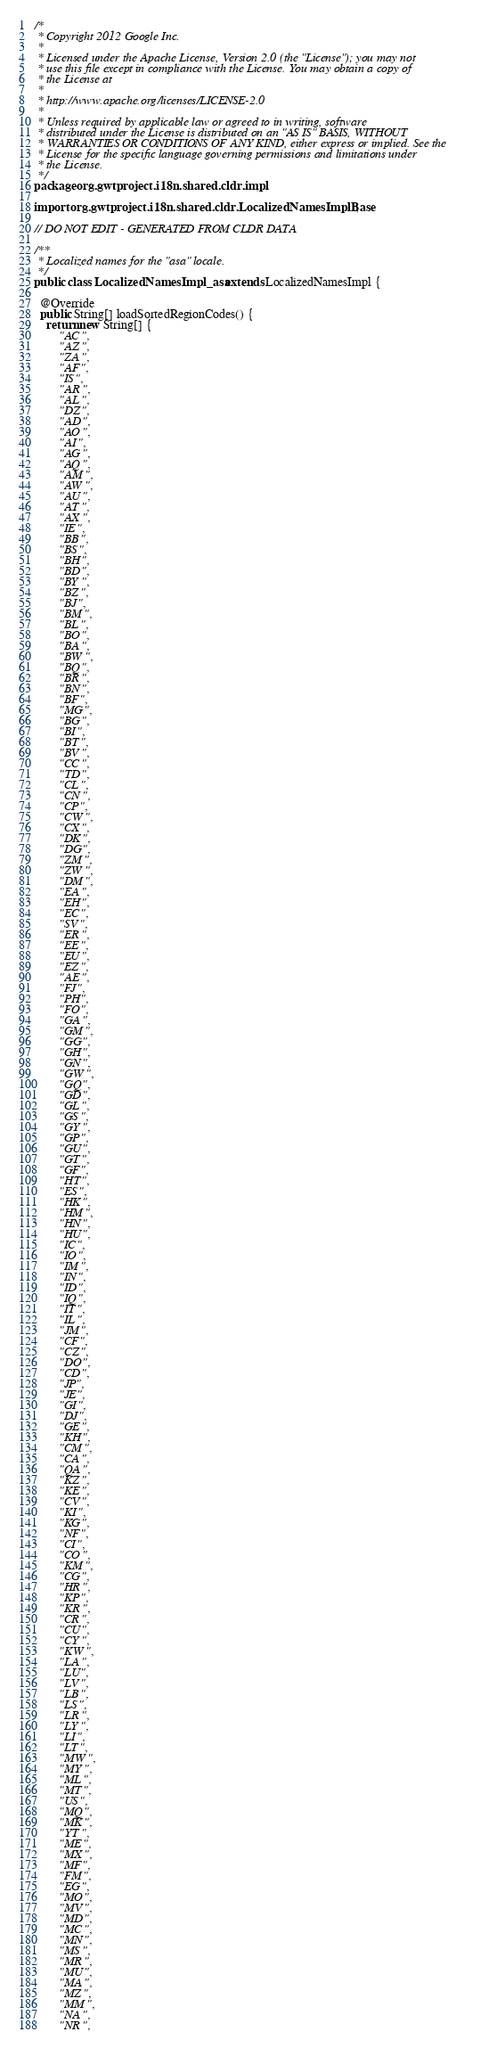<code> <loc_0><loc_0><loc_500><loc_500><_Java_>/*
 * Copyright 2012 Google Inc.
 * 
 * Licensed under the Apache License, Version 2.0 (the "License"); you may not
 * use this file except in compliance with the License. You may obtain a copy of
 * the License at
 * 
 * http://www.apache.org/licenses/LICENSE-2.0
 * 
 * Unless required by applicable law or agreed to in writing, software
 * distributed under the License is distributed on an "AS IS" BASIS, WITHOUT
 * WARRANTIES OR CONDITIONS OF ANY KIND, either express or implied. See the
 * License for the specific language governing permissions and limitations under
 * the License.
 */
package org.gwtproject.i18n.shared.cldr.impl;

import org.gwtproject.i18n.shared.cldr.LocalizedNamesImplBase;

// DO NOT EDIT - GENERATED FROM CLDR DATA

/**
 * Localized names for the "asa" locale.
 */
public class LocalizedNamesImpl_asa extends LocalizedNamesImpl {

  @Override
  public String[] loadSortedRegionCodes() {
    return new String[] {
        "AC",
        "AZ",
        "ZA",
        "AF",
        "IS",
        "AR",
        "AL",
        "DZ",
        "AD",
        "AO",
        "AI",
        "AG",
        "AQ",
        "AM",
        "AW",
        "AU",
        "AT",
        "AX",
        "IE",
        "BB",
        "BS",
        "BH",
        "BD",
        "BY",
        "BZ",
        "BJ",
        "BM",
        "BL",
        "BO",
        "BA",
        "BW",
        "BQ",
        "BR",
        "BN",
        "BF",
        "MG",
        "BG",
        "BI",
        "BT",
        "BV",
        "CC",
        "TD",
        "CL",
        "CN",
        "CP",
        "CW",
        "CX",
        "DK",
        "DG",
        "ZM",
        "ZW",
        "DM",
        "EA",
        "EH",
        "EC",
        "SV",
        "ER",
        "EE",
        "EU",
        "EZ",
        "AE",
        "FJ",
        "PH",
        "FO",
        "GA",
        "GM",
        "GG",
        "GH",
        "GN",
        "GW",
        "GQ",
        "GD",
        "GL",
        "GS",
        "GY",
        "GP",
        "GU",
        "GT",
        "GF",
        "HT",
        "ES",
        "HK",
        "HM",
        "HN",
        "HU",
        "IC",
        "IO",
        "IM",
        "IN",
        "ID",
        "IQ",
        "IT",
        "IL",
        "JM",
        "CF",
        "CZ",
        "DO",
        "CD",
        "JP",
        "JE",
        "GI",
        "DJ",
        "GE",
        "KH",
        "CM",
        "CA",
        "QA",
        "KZ",
        "KE",
        "CV",
        "KI",
        "KG",
        "NF",
        "CI",
        "CO",
        "KM",
        "CG",
        "HR",
        "KP",
        "KR",
        "CR",
        "CU",
        "CY",
        "KW",
        "LA",
        "LU",
        "LV",
        "LB",
        "LS",
        "LR",
        "LY",
        "LI",
        "LT",
        "MW",
        "MY",
        "ML",
        "MT",
        "US",
        "MQ",
        "MK",
        "YT",
        "ME",
        "MX",
        "MF",
        "FM",
        "EG",
        "MO",
        "MV",
        "MD",
        "MC",
        "MN",
        "MS",
        "MR",
        "MU",
        "MA",
        "MZ",
        "MM",
        "NA",
        "NR",</code> 